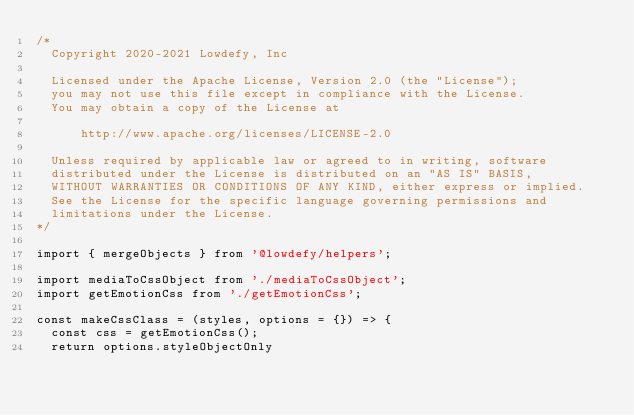<code> <loc_0><loc_0><loc_500><loc_500><_JavaScript_>/*
  Copyright 2020-2021 Lowdefy, Inc

  Licensed under the Apache License, Version 2.0 (the "License");
  you may not use this file except in compliance with the License.
  You may obtain a copy of the License at

      http://www.apache.org/licenses/LICENSE-2.0

  Unless required by applicable law or agreed to in writing, software
  distributed under the License is distributed on an "AS IS" BASIS,
  WITHOUT WARRANTIES OR CONDITIONS OF ANY KIND, either express or implied.
  See the License for the specific language governing permissions and
  limitations under the License.
*/

import { mergeObjects } from '@lowdefy/helpers';

import mediaToCssObject from './mediaToCssObject';
import getEmotionCss from './getEmotionCss';

const makeCssClass = (styles, options = {}) => {
  const css = getEmotionCss();
  return options.styleObjectOnly</code> 